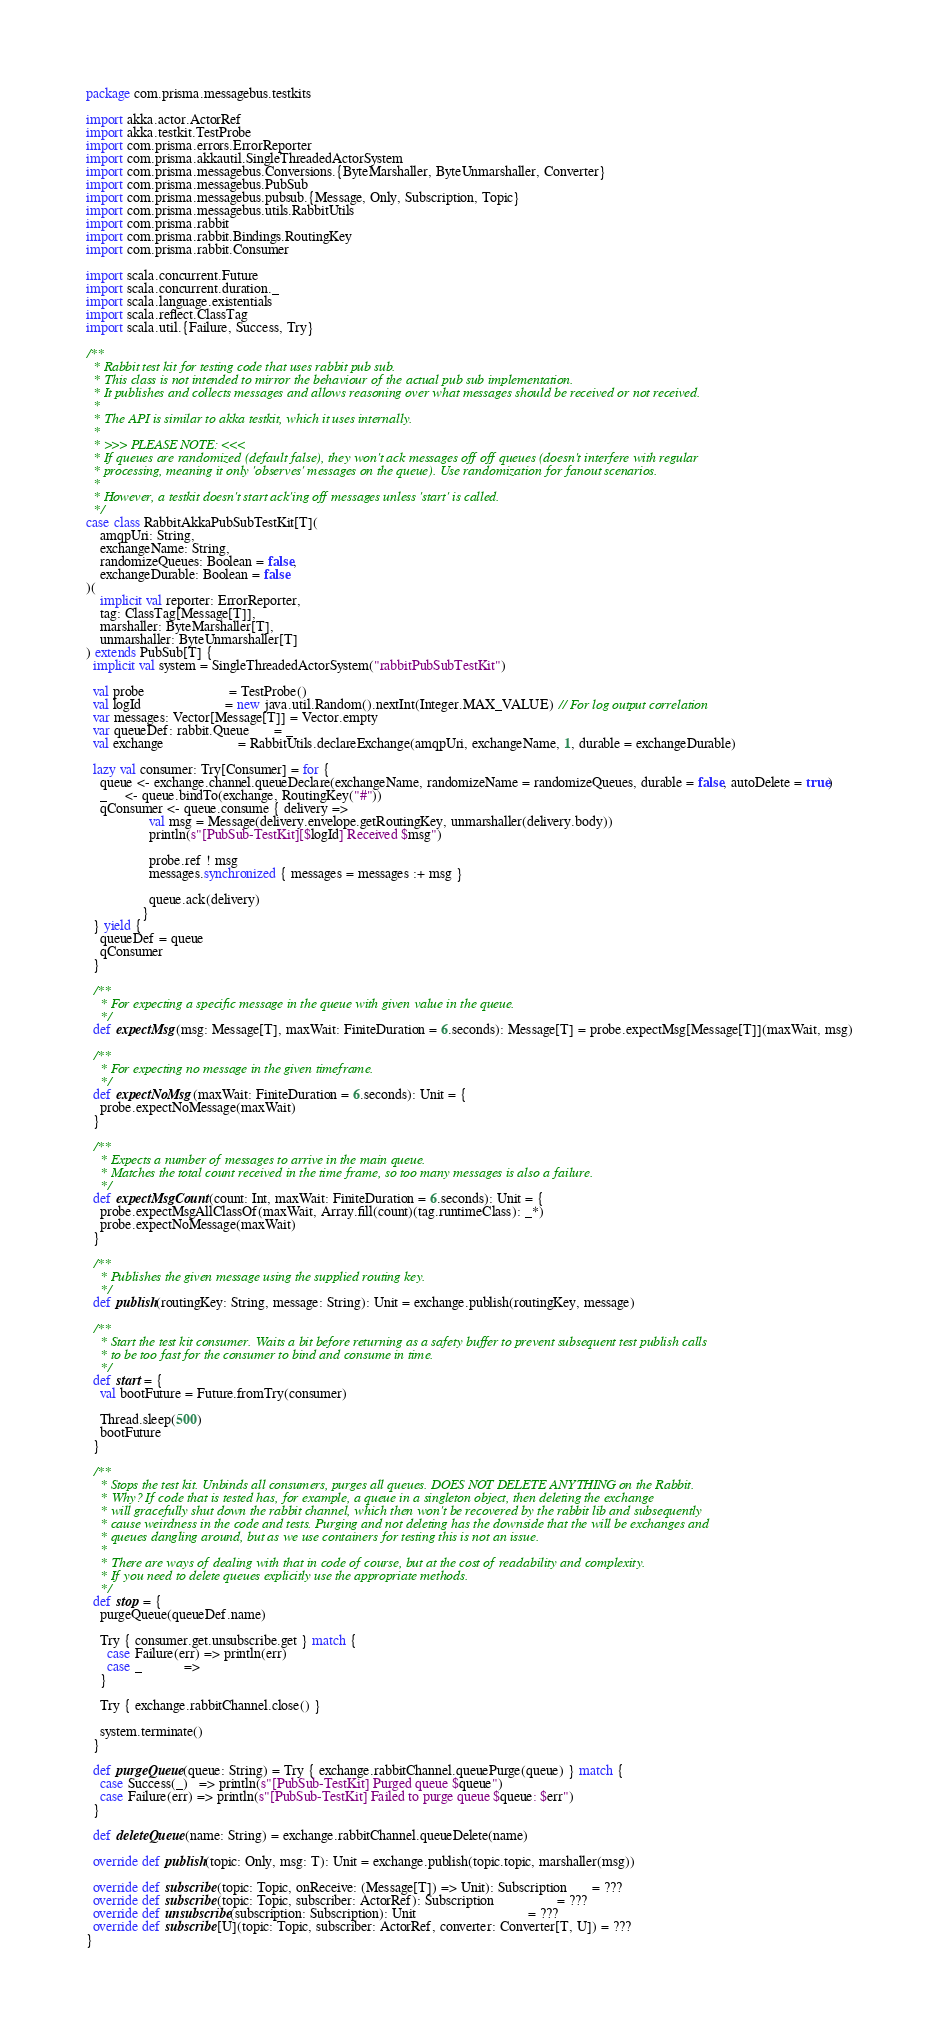Convert code to text. <code><loc_0><loc_0><loc_500><loc_500><_Scala_>package com.prisma.messagebus.testkits

import akka.actor.ActorRef
import akka.testkit.TestProbe
import com.prisma.errors.ErrorReporter
import com.prisma.akkautil.SingleThreadedActorSystem
import com.prisma.messagebus.Conversions.{ByteMarshaller, ByteUnmarshaller, Converter}
import com.prisma.messagebus.PubSub
import com.prisma.messagebus.pubsub.{Message, Only, Subscription, Topic}
import com.prisma.messagebus.utils.RabbitUtils
import com.prisma.rabbit
import com.prisma.rabbit.Bindings.RoutingKey
import com.prisma.rabbit.Consumer

import scala.concurrent.Future
import scala.concurrent.duration._
import scala.language.existentials
import scala.reflect.ClassTag
import scala.util.{Failure, Success, Try}

/**
  * Rabbit test kit for testing code that uses rabbit pub sub.
  * This class is not intended to mirror the behaviour of the actual pub sub implementation.
  * It publishes and collects messages and allows reasoning over what messages should be received or not received.
  *
  * The API is similar to akka testkit, which it uses internally.
  *
  * >>> PLEASE NOTE: <<<
  * If queues are randomized (default false), they won't ack messages off off queues (doesn't interfere with regular
  * processing, meaning it only 'observes' messages on the queue). Use randomization for fanout scenarios.
  *
  * However, a testkit doesn't start ack'ing off messages unless 'start' is called.
  */
case class RabbitAkkaPubSubTestKit[T](
    amqpUri: String,
    exchangeName: String,
    randomizeQueues: Boolean = false,
    exchangeDurable: Boolean = false
)(
    implicit val reporter: ErrorReporter,
    tag: ClassTag[Message[T]],
    marshaller: ByteMarshaller[T],
    unmarshaller: ByteUnmarshaller[T]
) extends PubSub[T] {
  implicit val system = SingleThreadedActorSystem("rabbitPubSubTestKit")

  val probe                        = TestProbe()
  val logId                        = new java.util.Random().nextInt(Integer.MAX_VALUE) // For log output correlation
  var messages: Vector[Message[T]] = Vector.empty
  var queueDef: rabbit.Queue       = _
  val exchange                     = RabbitUtils.declareExchange(amqpUri, exchangeName, 1, durable = exchangeDurable)

  lazy val consumer: Try[Consumer] = for {
    queue <- exchange.channel.queueDeclare(exchangeName, randomizeName = randomizeQueues, durable = false, autoDelete = true)
    _     <- queue.bindTo(exchange, RoutingKey("#"))
    qConsumer <- queue.consume { delivery =>
                  val msg = Message(delivery.envelope.getRoutingKey, unmarshaller(delivery.body))
                  println(s"[PubSub-TestKit][$logId] Received $msg")

                  probe.ref ! msg
                  messages.synchronized { messages = messages :+ msg }

                  queue.ack(delivery)
                }
  } yield {
    queueDef = queue
    qConsumer
  }

  /**
    * For expecting a specific message in the queue with given value in the queue.
    */
  def expectMsg(msg: Message[T], maxWait: FiniteDuration = 6.seconds): Message[T] = probe.expectMsg[Message[T]](maxWait, msg)

  /**
    * For expecting no message in the given timeframe.
    */
  def expectNoMsg(maxWait: FiniteDuration = 6.seconds): Unit = {
    probe.expectNoMessage(maxWait)
  }

  /**
    * Expects a number of messages to arrive in the main queue.
    * Matches the total count received in the time frame, so too many messages is also a failure.
    */
  def expectMsgCount(count: Int, maxWait: FiniteDuration = 6.seconds): Unit = {
    probe.expectMsgAllClassOf(maxWait, Array.fill(count)(tag.runtimeClass): _*)
    probe.expectNoMessage(maxWait)
  }

  /**
    * Publishes the given message using the supplied routing key.
    */
  def publish(routingKey: String, message: String): Unit = exchange.publish(routingKey, message)

  /**
    * Start the test kit consumer. Waits a bit before returning as a safety buffer to prevent subsequent test publish calls
    * to be too fast for the consumer to bind and consume in time.
    */
  def start = {
    val bootFuture = Future.fromTry(consumer)

    Thread.sleep(500)
    bootFuture
  }

  /**
    * Stops the test kit. Unbinds all consumers, purges all queues. DOES NOT DELETE ANYTHING on the Rabbit.
    * Why? If code that is tested has, for example, a queue in a singleton object, then deleting the exchange
    * will gracefully shut down the rabbit channel, which then won't be recovered by the rabbit lib and subsequently
    * cause weirdness in the code and tests. Purging and not deleting has the downside that the will be exchanges and
    * queues dangling around, but as we use containers for testing this is not an issue.
    *
    * There are ways of dealing with that in code of course, but at the cost of readability and complexity.
    * If you need to delete queues explicitly use the appropriate methods.
    */
  def stop = {
    purgeQueue(queueDef.name)

    Try { consumer.get.unsubscribe.get } match {
      case Failure(err) => println(err)
      case _            =>
    }

    Try { exchange.rabbitChannel.close() }

    system.terminate()
  }

  def purgeQueue(queue: String) = Try { exchange.rabbitChannel.queuePurge(queue) } match {
    case Success(_)   => println(s"[PubSub-TestKit] Purged queue $queue")
    case Failure(err) => println(s"[PubSub-TestKit] Failed to purge queue $queue: $err")
  }

  def deleteQueue(name: String) = exchange.rabbitChannel.queueDelete(name)

  override def publish(topic: Only, msg: T): Unit = exchange.publish(topic.topic, marshaller(msg))

  override def subscribe(topic: Topic, onReceive: (Message[T]) => Unit): Subscription       = ???
  override def subscribe(topic: Topic, subscriber: ActorRef): Subscription                  = ???
  override def unsubscribe(subscription: Subscription): Unit                                = ???
  override def subscribe[U](topic: Topic, subscriber: ActorRef, converter: Converter[T, U]) = ???
}
</code> 